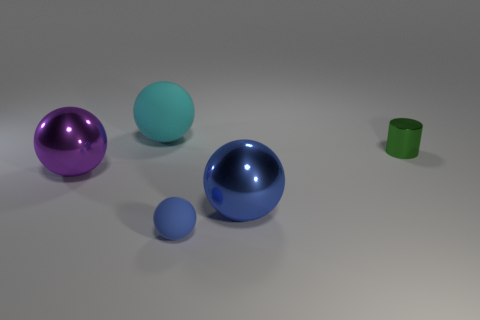What number of objects are shiny balls that are right of the big purple shiny ball or shiny objects?
Provide a succinct answer. 3. Does the small green thing have the same material as the large sphere behind the large purple metallic object?
Ensure brevity in your answer.  No. What is the shape of the big metal thing that is left of the small object that is in front of the blue metal object?
Make the answer very short. Sphere. Is the color of the small rubber thing the same as the large metal ball to the right of the purple shiny object?
Make the answer very short. Yes. What is the shape of the purple shiny object?
Make the answer very short. Sphere. There is a metallic sphere behind the big thing right of the big cyan rubber thing; how big is it?
Give a very brief answer. Large. Are there an equal number of big purple spheres that are to the right of the small cylinder and metal spheres right of the cyan object?
Give a very brief answer. No. The large ball that is to the left of the blue rubber ball and in front of the big rubber thing is made of what material?
Make the answer very short. Metal. Is the size of the blue rubber thing the same as the shiny thing left of the small rubber ball?
Ensure brevity in your answer.  No. What number of other things are there of the same color as the small sphere?
Ensure brevity in your answer.  1. 